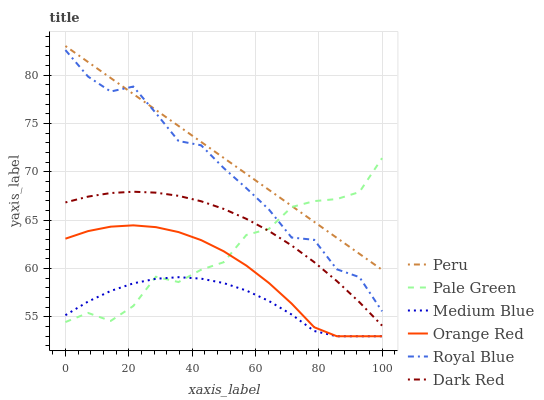Does Medium Blue have the minimum area under the curve?
Answer yes or no. Yes. Does Peru have the maximum area under the curve?
Answer yes or no. Yes. Does Royal Blue have the minimum area under the curve?
Answer yes or no. No. Does Royal Blue have the maximum area under the curve?
Answer yes or no. No. Is Peru the smoothest?
Answer yes or no. Yes. Is Pale Green the roughest?
Answer yes or no. Yes. Is Medium Blue the smoothest?
Answer yes or no. No. Is Medium Blue the roughest?
Answer yes or no. No. Does Medium Blue have the lowest value?
Answer yes or no. Yes. Does Royal Blue have the lowest value?
Answer yes or no. No. Does Peru have the highest value?
Answer yes or no. Yes. Does Royal Blue have the highest value?
Answer yes or no. No. Is Medium Blue less than Peru?
Answer yes or no. Yes. Is Peru greater than Orange Red?
Answer yes or no. Yes. Does Dark Red intersect Pale Green?
Answer yes or no. Yes. Is Dark Red less than Pale Green?
Answer yes or no. No. Is Dark Red greater than Pale Green?
Answer yes or no. No. Does Medium Blue intersect Peru?
Answer yes or no. No. 